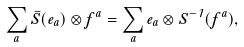<formula> <loc_0><loc_0><loc_500><loc_500>\sum _ { a } \bar { S } ( e _ { a } ) \otimes f ^ { a } = \sum _ { a } e _ { a } \otimes S ^ { - 1 } ( f ^ { a } ) ,</formula> 